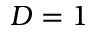Convert formula to latex. <formula><loc_0><loc_0><loc_500><loc_500>D = 1</formula> 